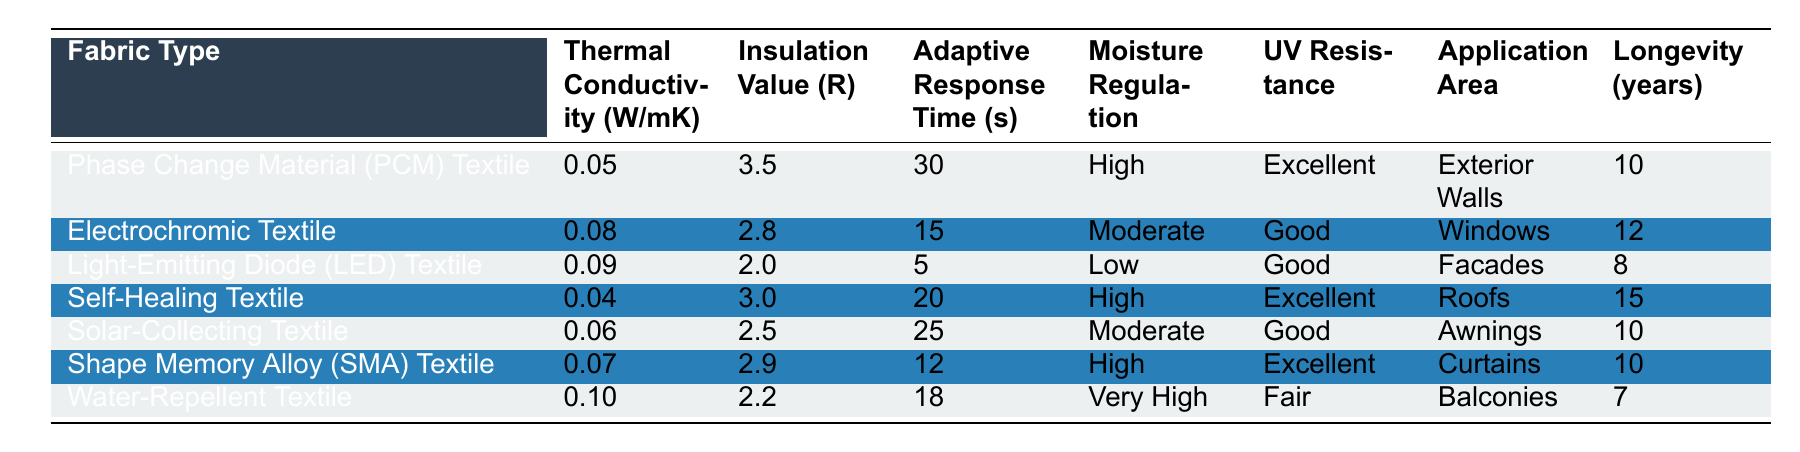What is the insulation value (R) of the Self-Healing Textile? The table shows that the insulation value (R) for the Self-Healing Textile is 3.0.
Answer: 3.0 Which fabric type has the highest thermal conductivity? Looking at the thermal conductivity values, the Water-Repellent Textile has the highest value at 0.10 W/mK.
Answer: Water-Repellent Textile What is the average adaptive response time for all the textile types? To find the average adaptive response time, sum the response times: 30 + 15 + 5 + 20 + 25 + 12 + 18 = 125 seconds. There are 7 fabric types, so the average is 125/7 = 17.86 seconds, which can be rounded to 18 seconds.
Answer: 18 seconds Is the moisture regulation for the Light-Emitting Diode (LED) Textile characterized as high? According to the table, the moisture regulation for the Light-Emitting Diode (LED) Textile is classified as Low, thus it is not high.
Answer: No Which fabric types have a longevity of at least 10 years and good UV resistance? The table indicates that the Electrochromic Textile and Shape Memory Alloy (SMA) Textile both have UV resistance classified as Good and longevities of 12 and 10 years, respectively.
Answer: Electrochromic Textile and Shape Memory Alloy (SMA) Textile What is the difference in insulation value between the Phase Change Material (PCM) Textile and the Solar-Collecting Textile? The insulation value for PCM Textile is 3.5 and for Solar-Collecting Textile is 2.5. The difference is 3.5 - 2.5 = 1.0.
Answer: 1.0 Which fabric type has the fastest adaptive response time? The table indicates that the Light-Emitting Diode (LED) Textile has the fastest adaptive response time at 5 seconds.
Answer: Light-Emitting Diode (LED) Textile How many fabric types have high moisture regulation? From the table, the fabric types with high moisture regulation are the Phase Change Material (PCM) Textile, Self-Healing Textile, and Shape Memory Alloy (SMA) Textile. Thus, there are three fabric types with high moisture regulation.
Answer: 3 What is the overall trend in adaptive response times among these fabric types? Upon examining the adaptive response times, it appears that they range from 5 seconds (LED Textile) to 30 seconds (PCM Textile). Overall, there is a trend of decreasing response time among certain textiles, indicating faster adaptability in some fabrics.
Answer: Generally decreasing trend Is there any fabric type that offers very high moisture regulation? The Water-Repellent Textile provides very high moisture regulation as specified in the table.
Answer: Yes 